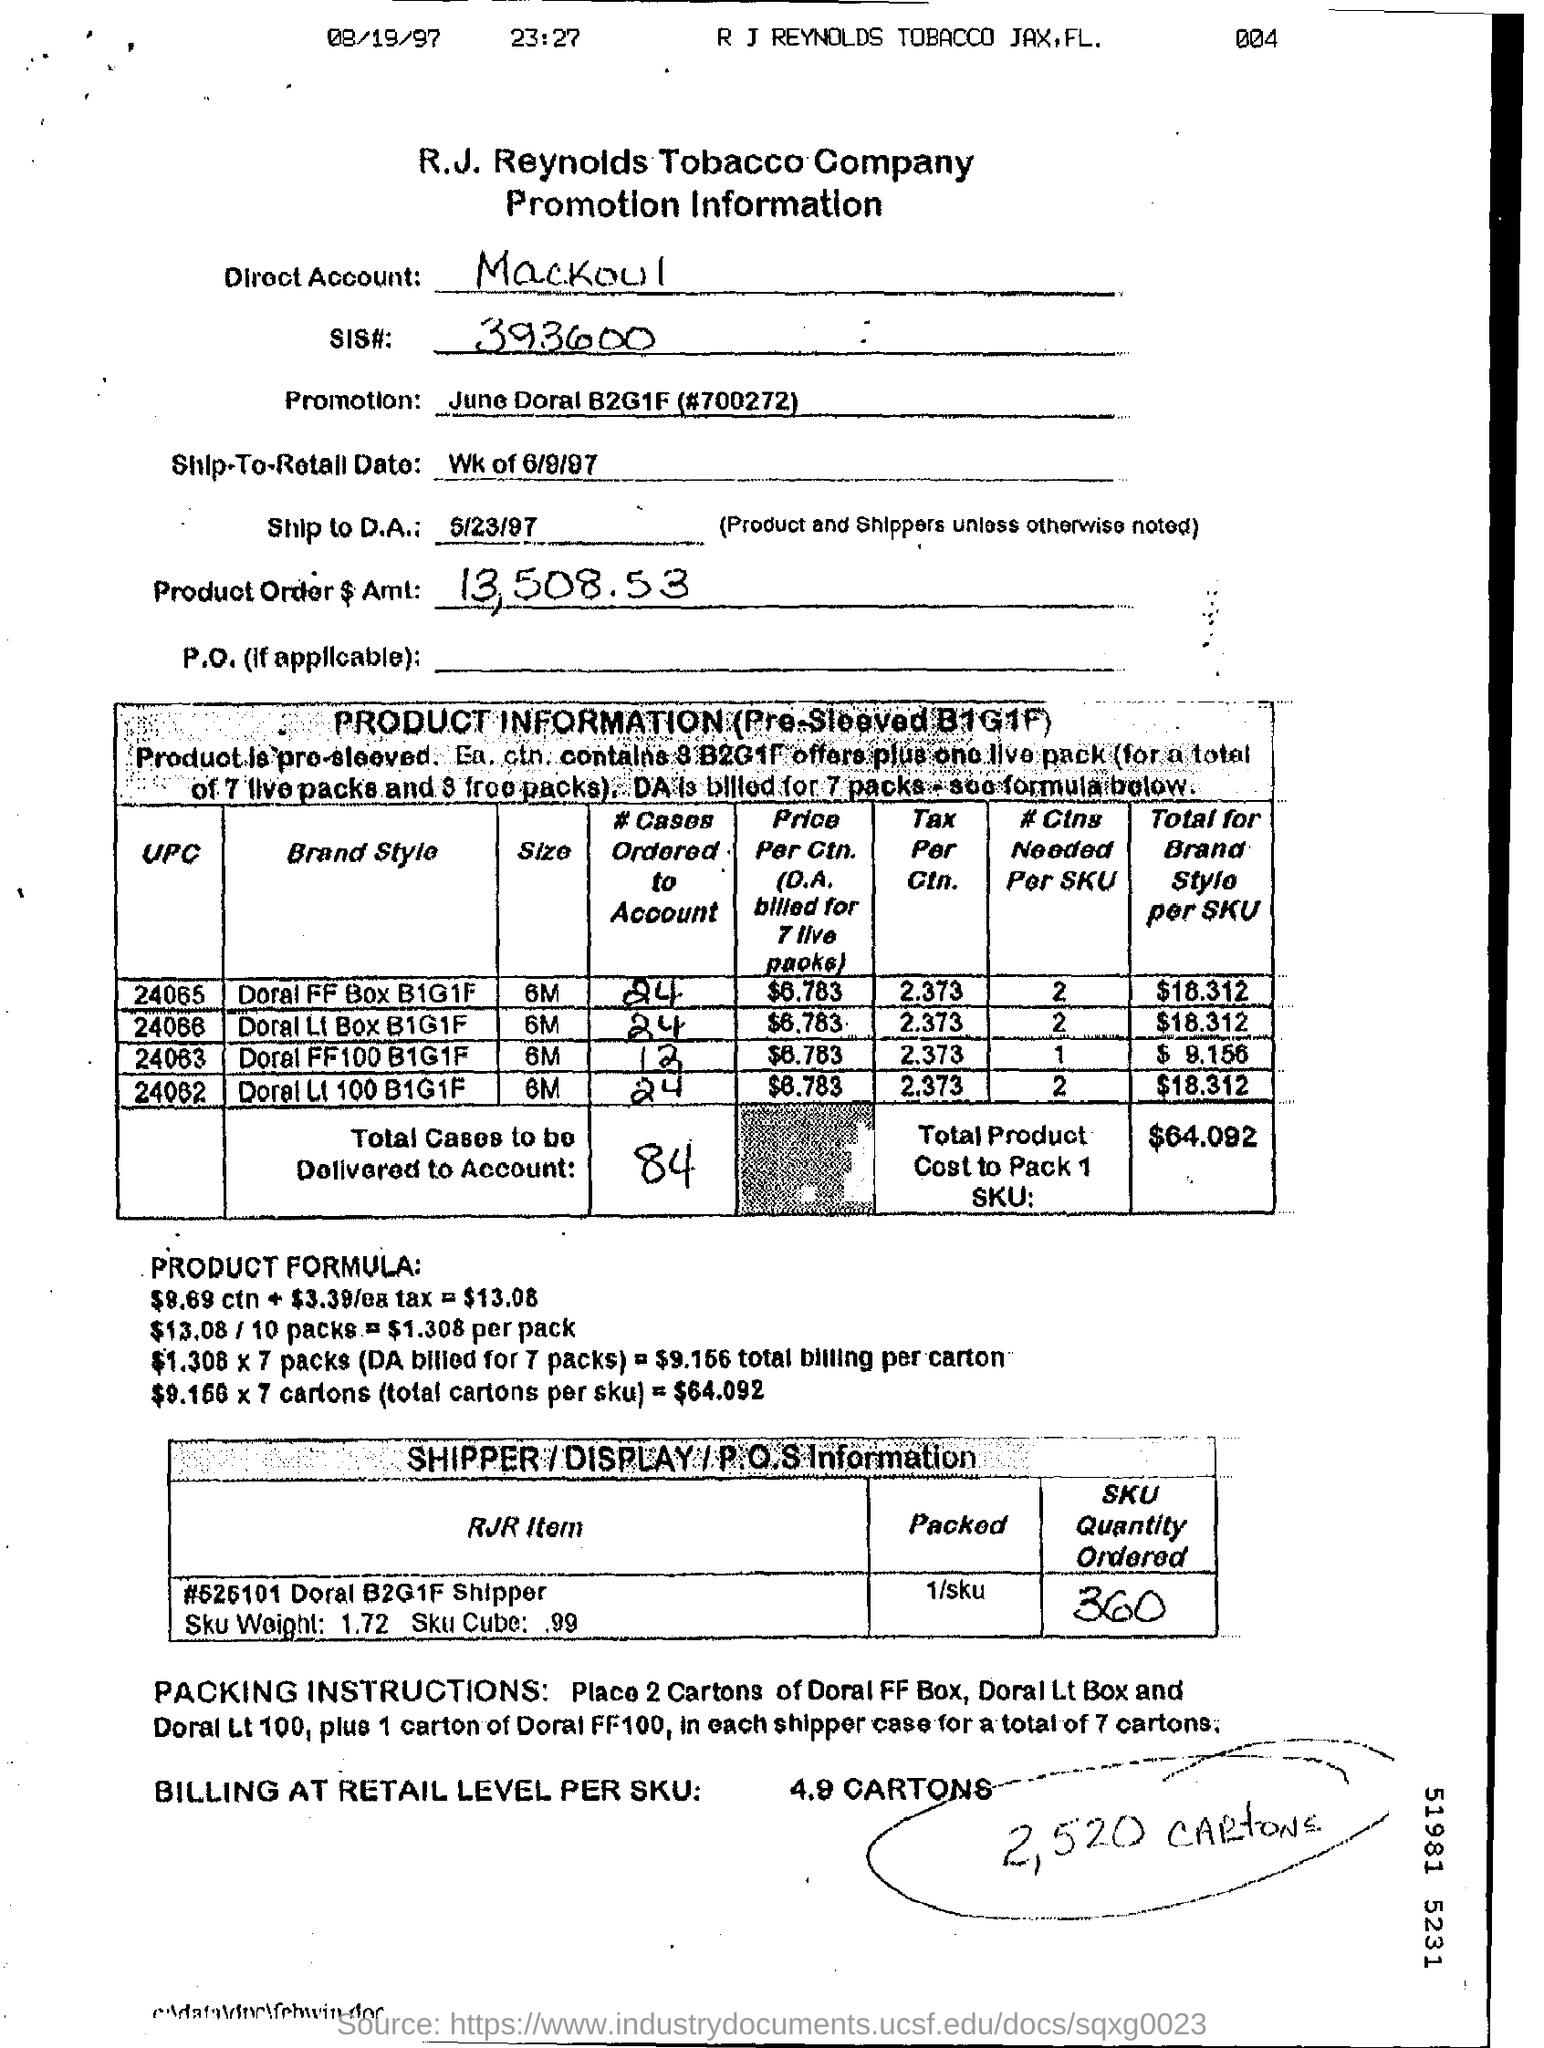Mention a couple of crucial points in this snapshot. It is estimated that a total of 84 cases will be delivered to the account. At 23:27, the time mentioned is... The date mentioned is August 19, 1997. Mackoul is mentioned in the direct account. We have received an order for 360 units of SKU. 